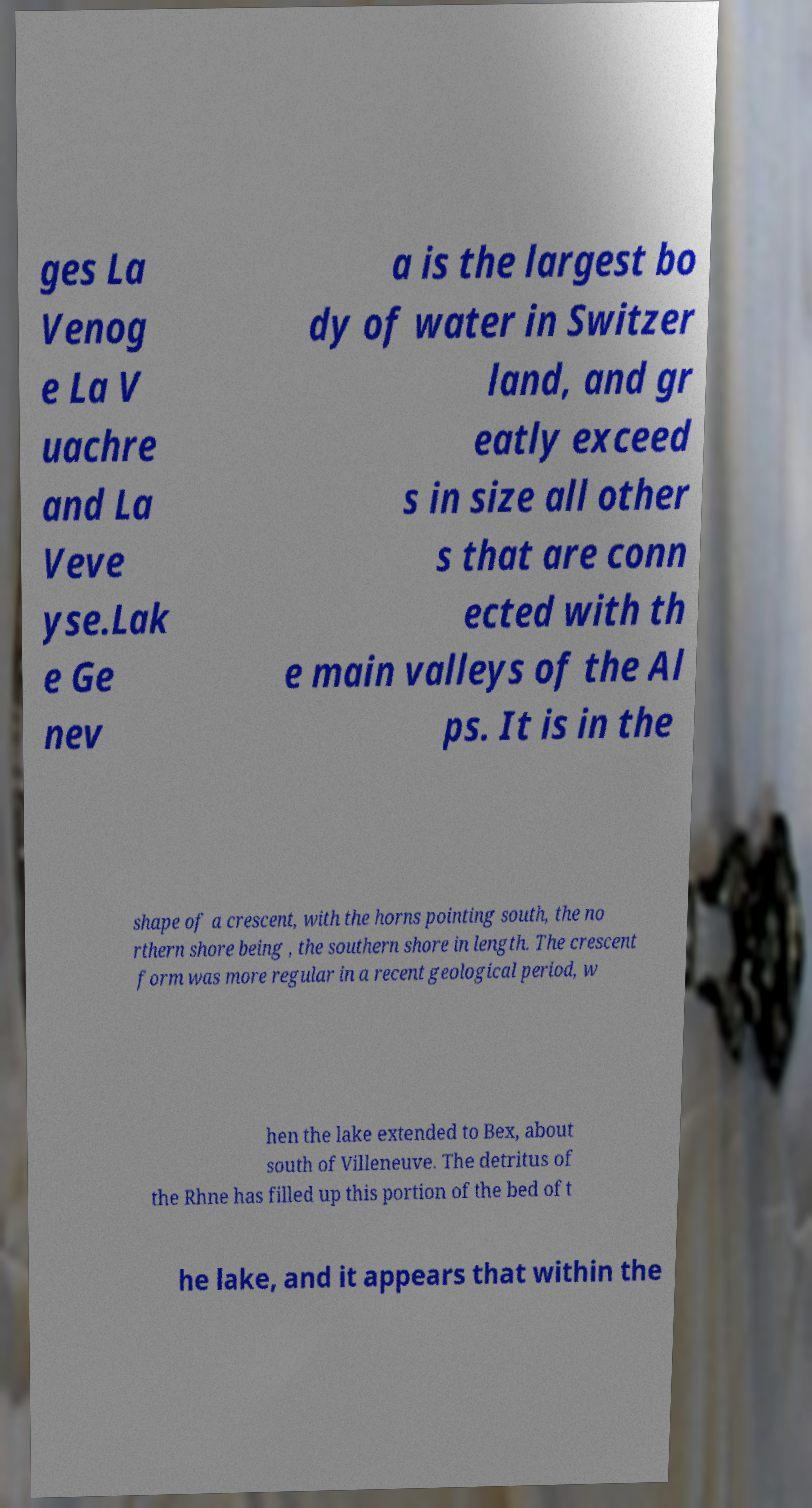Could you extract and type out the text from this image? ges La Venog e La V uachre and La Veve yse.Lak e Ge nev a is the largest bo dy of water in Switzer land, and gr eatly exceed s in size all other s that are conn ected with th e main valleys of the Al ps. It is in the shape of a crescent, with the horns pointing south, the no rthern shore being , the southern shore in length. The crescent form was more regular in a recent geological period, w hen the lake extended to Bex, about south of Villeneuve. The detritus of the Rhne has filled up this portion of the bed of t he lake, and it appears that within the 